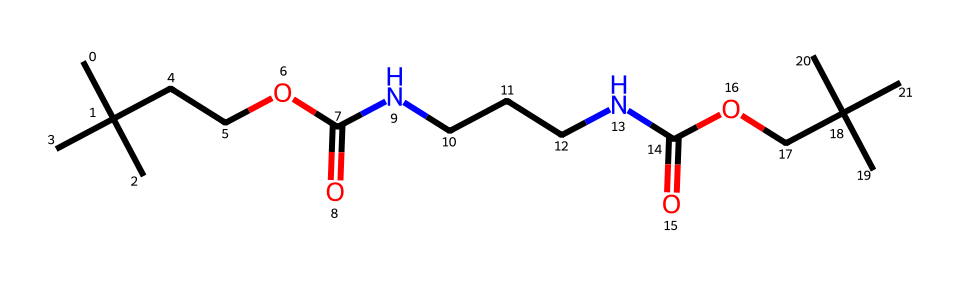What is the primary functional group in this polyurethane? In the given structure, the functional group is indicated by the presence of a carbonyl (C=O) adjacent to a nitrogen atom (N). This is characteristic of the amine and urethane groups found in polyurethanes.
Answer: urethane How many nitrogen atoms are present in the structure? By examining the SMILES representation, we identify two nitrogen atoms (N) in the structure. Specifically, they are located between the carbon chains, partaking in amine functionalities.
Answer: 2 What type of bonds can be identified in this polyurethane structure? The structure contains various types of bonds, including single (C-C, C-N) and double bonds (C=O). The combination of these bonds contributes to the polymer's strength and properties.
Answer: single and double bonds What is the general use of this type of polyurethane in bowling balls? Polyurethanes are commonly used in the cores of bowling balls for their durability and elasticity, which provide a good balance of traction and control on bowling lanes.
Answer: durability and elasticity How many carbon atoms are present in this structure? By counting the carbon atoms (C) in the given SMILES, there are a total of 12 carbon atoms present, contributing to the overall framework of the polyurethane polymer.
Answer: 12 Which property of this polyurethane enhances its performance in bowling balls? The flexibility and resilience of the polyurethane contribute to the collision physics during the bowling motion, which enhances performance. This is primarily due to its elastomeric nature as a polymer.
Answer: flexibility and resilience 